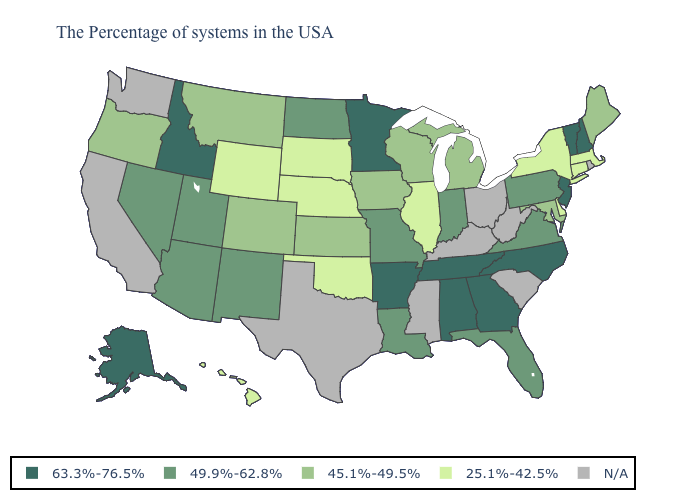Name the states that have a value in the range 45.1%-49.5%?
Keep it brief. Maine, Maryland, Michigan, Wisconsin, Iowa, Kansas, Colorado, Montana, Oregon. Which states have the lowest value in the West?
Concise answer only. Wyoming, Hawaii. Name the states that have a value in the range 25.1%-42.5%?
Short answer required. Massachusetts, Connecticut, New York, Delaware, Illinois, Nebraska, Oklahoma, South Dakota, Wyoming, Hawaii. Name the states that have a value in the range N/A?
Write a very short answer. Rhode Island, South Carolina, West Virginia, Ohio, Kentucky, Mississippi, Texas, California, Washington. Among the states that border Pennsylvania , does New Jersey have the highest value?
Short answer required. Yes. What is the lowest value in the USA?
Keep it brief. 25.1%-42.5%. What is the value of California?
Write a very short answer. N/A. What is the value of Louisiana?
Write a very short answer. 49.9%-62.8%. What is the value of Hawaii?
Write a very short answer. 25.1%-42.5%. What is the value of Arkansas?
Answer briefly. 63.3%-76.5%. Does the map have missing data?
Give a very brief answer. Yes. What is the value of Louisiana?
Quick response, please. 49.9%-62.8%. Does the first symbol in the legend represent the smallest category?
Quick response, please. No. 